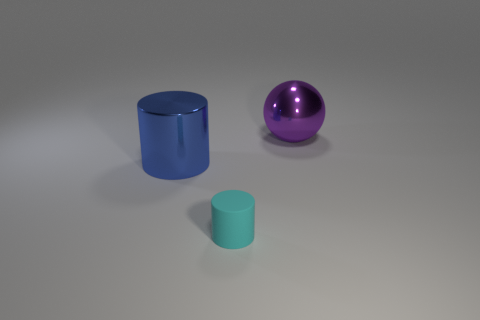How many other objects are there of the same material as the large purple thing?
Ensure brevity in your answer.  1. How many small cyan matte objects are the same shape as the large blue shiny thing?
Provide a short and direct response. 1. Are there any other things that have the same shape as the purple metal object?
Offer a very short reply. No. The large metal object that is on the right side of the large thing in front of the metallic thing that is right of the shiny cylinder is what color?
Ensure brevity in your answer.  Purple. What number of small objects are either gray matte blocks or blue metal objects?
Make the answer very short. 0. Is the number of big blue objects that are right of the small object the same as the number of cylinders?
Offer a terse response. No. There is a metallic ball; are there any tiny cyan cylinders behind it?
Provide a succinct answer. No. How many rubber objects are cylinders or large green cubes?
Provide a short and direct response. 1. There is a cyan thing; what number of metal cylinders are right of it?
Your response must be concise. 0. Is there a metallic ball of the same size as the blue shiny cylinder?
Ensure brevity in your answer.  Yes. 